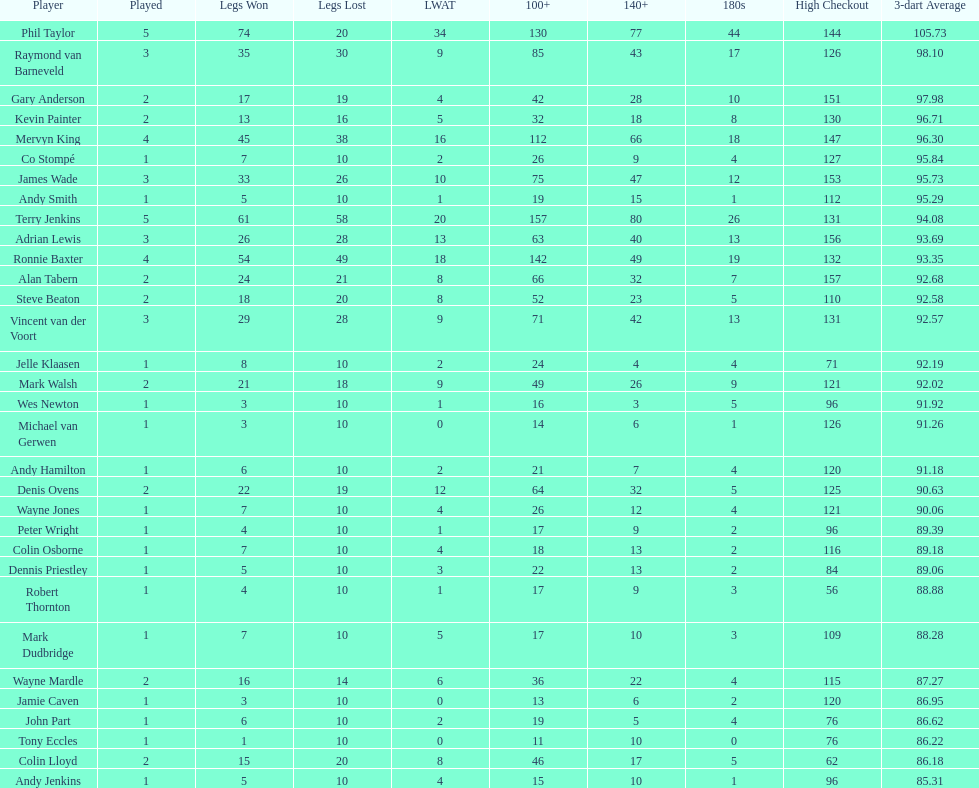What is the name of the next player after mark walsh? Wes Newton. 